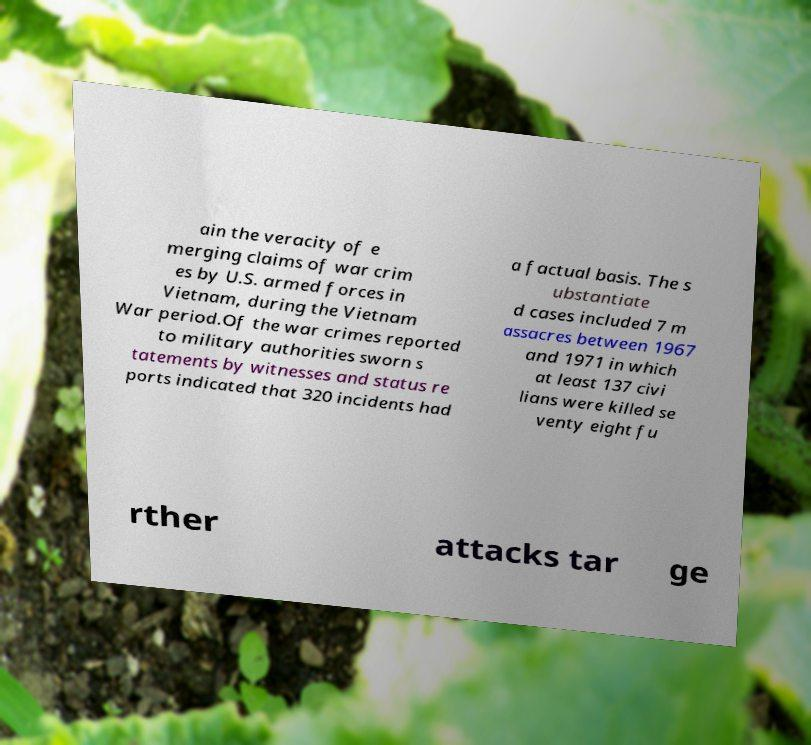Please identify and transcribe the text found in this image. ain the veracity of e merging claims of war crim es by U.S. armed forces in Vietnam, during the Vietnam War period.Of the war crimes reported to military authorities sworn s tatements by witnesses and status re ports indicated that 320 incidents had a factual basis. The s ubstantiate d cases included 7 m assacres between 1967 and 1971 in which at least 137 civi lians were killed se venty eight fu rther attacks tar ge 